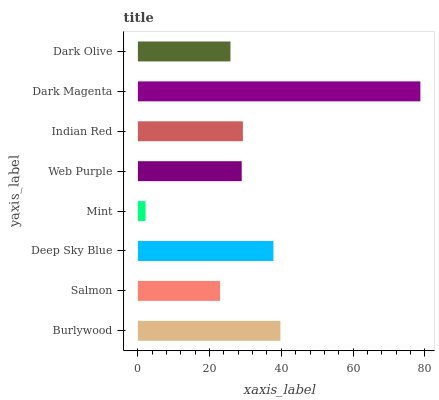Is Mint the minimum?
Answer yes or no. Yes. Is Dark Magenta the maximum?
Answer yes or no. Yes. Is Salmon the minimum?
Answer yes or no. No. Is Salmon the maximum?
Answer yes or no. No. Is Burlywood greater than Salmon?
Answer yes or no. Yes. Is Salmon less than Burlywood?
Answer yes or no. Yes. Is Salmon greater than Burlywood?
Answer yes or no. No. Is Burlywood less than Salmon?
Answer yes or no. No. Is Indian Red the high median?
Answer yes or no. Yes. Is Web Purple the low median?
Answer yes or no. Yes. Is Dark Magenta the high median?
Answer yes or no. No. Is Indian Red the low median?
Answer yes or no. No. 